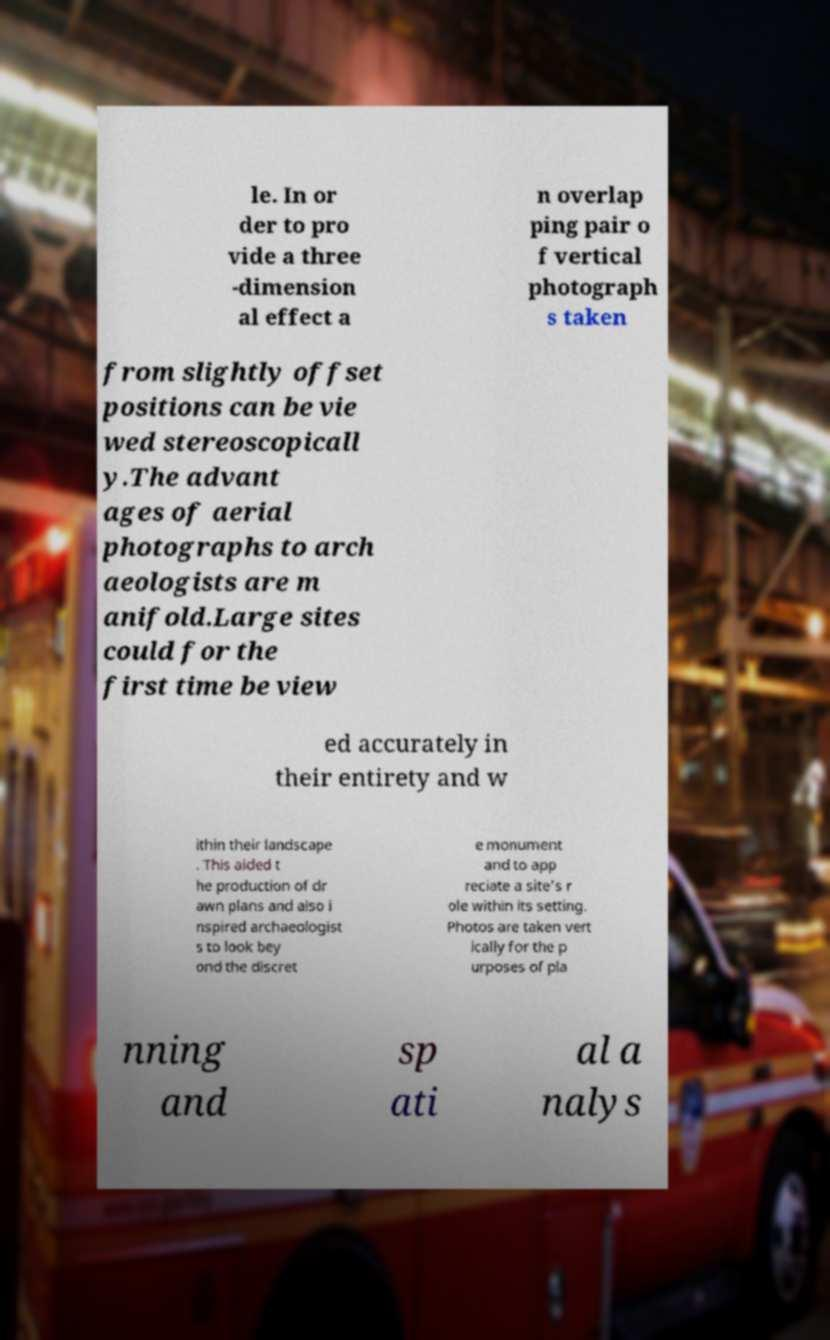Please identify and transcribe the text found in this image. le. In or der to pro vide a three -dimension al effect a n overlap ping pair o f vertical photograph s taken from slightly offset positions can be vie wed stereoscopicall y.The advant ages of aerial photographs to arch aeologists are m anifold.Large sites could for the first time be view ed accurately in their entirety and w ithin their landscape . This aided t he production of dr awn plans and also i nspired archaeologist s to look bey ond the discret e monument and to app reciate a site's r ole within its setting. Photos are taken vert ically for the p urposes of pla nning and sp ati al a nalys 